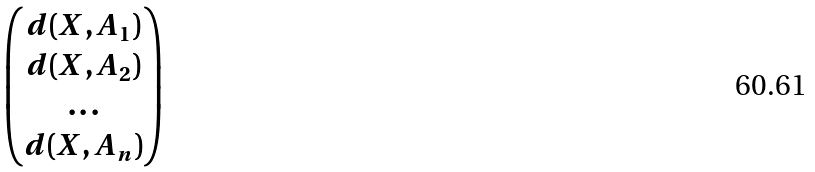<formula> <loc_0><loc_0><loc_500><loc_500>\begin{pmatrix} d ( X , A _ { 1 } ) \\ d ( X , A _ { 2 } ) \\ \dots \\ d ( X , A _ { n } ) \end{pmatrix}</formula> 